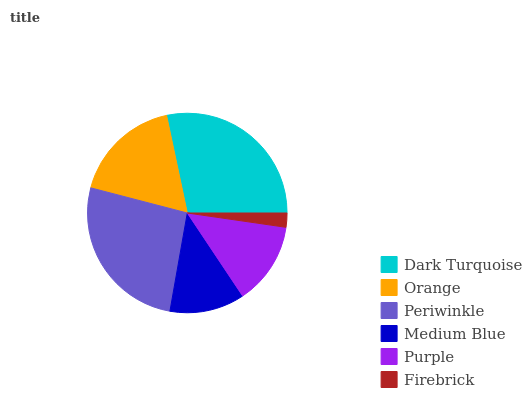Is Firebrick the minimum?
Answer yes or no. Yes. Is Dark Turquoise the maximum?
Answer yes or no. Yes. Is Orange the minimum?
Answer yes or no. No. Is Orange the maximum?
Answer yes or no. No. Is Dark Turquoise greater than Orange?
Answer yes or no. Yes. Is Orange less than Dark Turquoise?
Answer yes or no. Yes. Is Orange greater than Dark Turquoise?
Answer yes or no. No. Is Dark Turquoise less than Orange?
Answer yes or no. No. Is Orange the high median?
Answer yes or no. Yes. Is Purple the low median?
Answer yes or no. Yes. Is Medium Blue the high median?
Answer yes or no. No. Is Firebrick the low median?
Answer yes or no. No. 